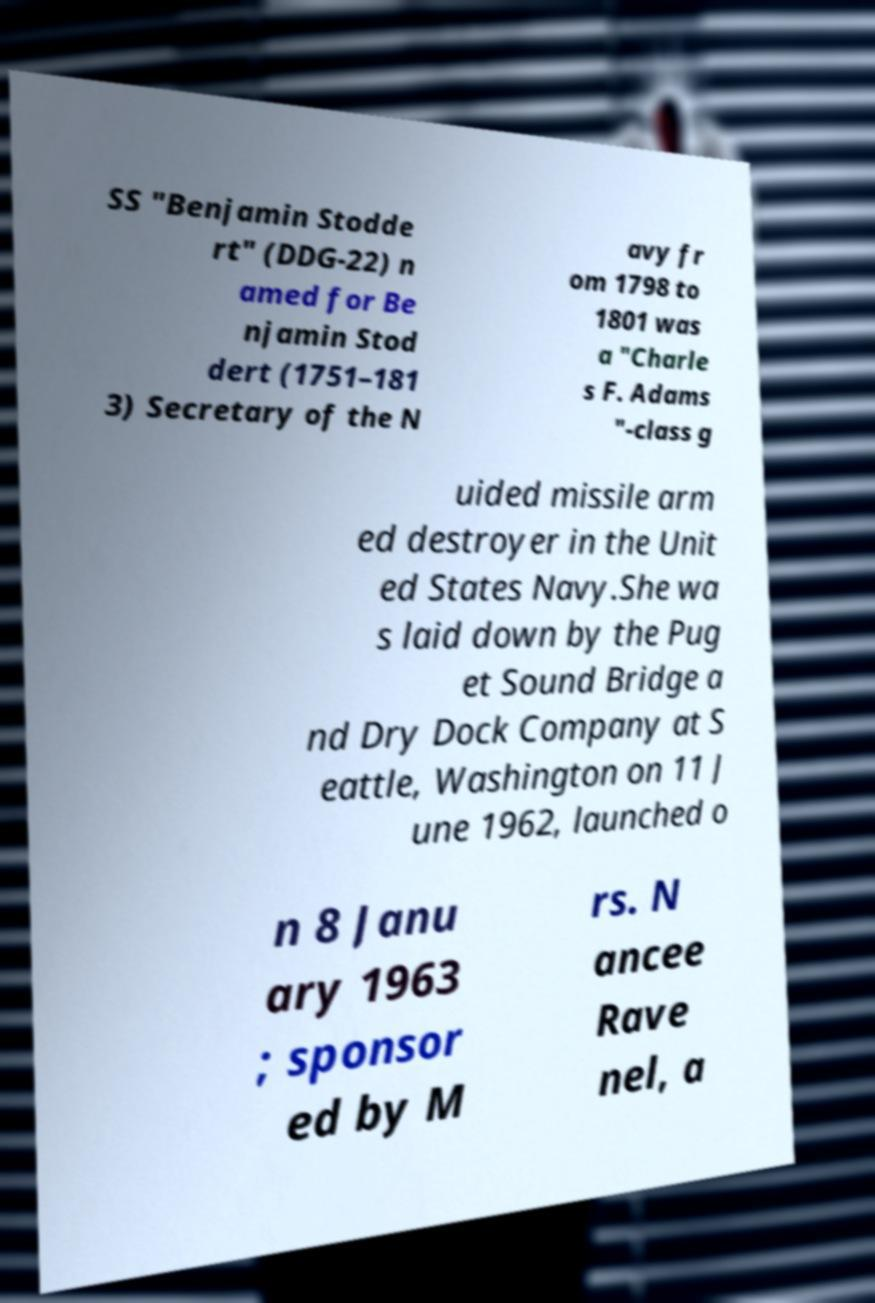For documentation purposes, I need the text within this image transcribed. Could you provide that? SS "Benjamin Stodde rt" (DDG-22) n amed for Be njamin Stod dert (1751–181 3) Secretary of the N avy fr om 1798 to 1801 was a "Charle s F. Adams "-class g uided missile arm ed destroyer in the Unit ed States Navy.She wa s laid down by the Pug et Sound Bridge a nd Dry Dock Company at S eattle, Washington on 11 J une 1962, launched o n 8 Janu ary 1963 ; sponsor ed by M rs. N ancee Rave nel, a 